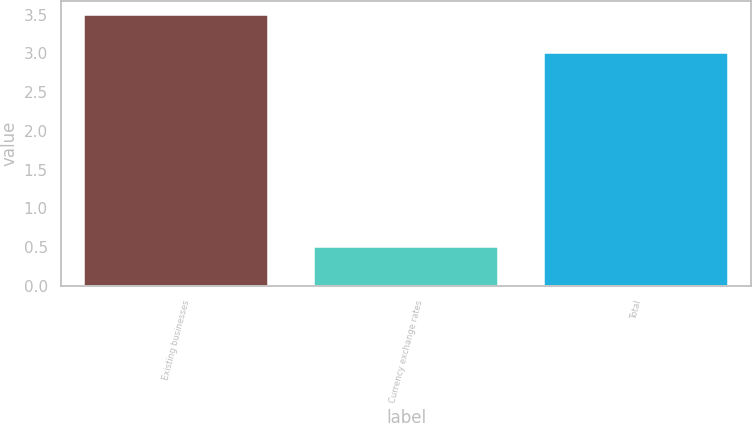<chart> <loc_0><loc_0><loc_500><loc_500><bar_chart><fcel>Existing businesses<fcel>Currency exchange rates<fcel>Total<nl><fcel>3.5<fcel>0.5<fcel>3<nl></chart> 